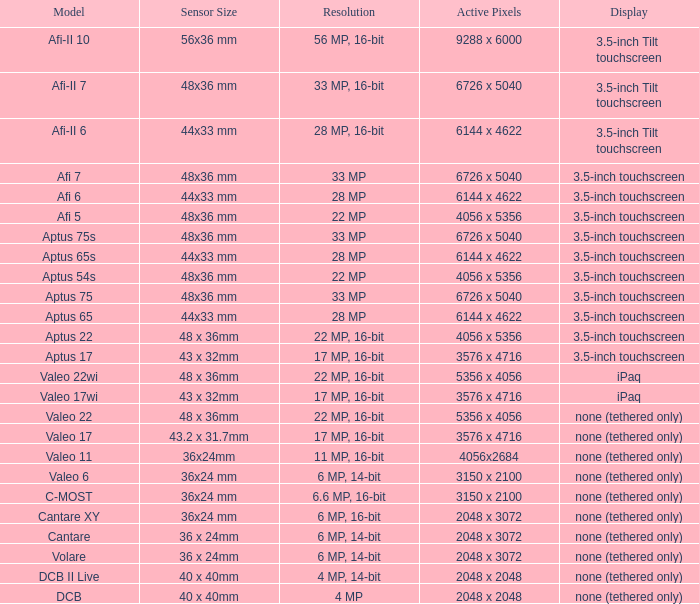What are the active pixels of the cantare model? 2048 x 3072. 